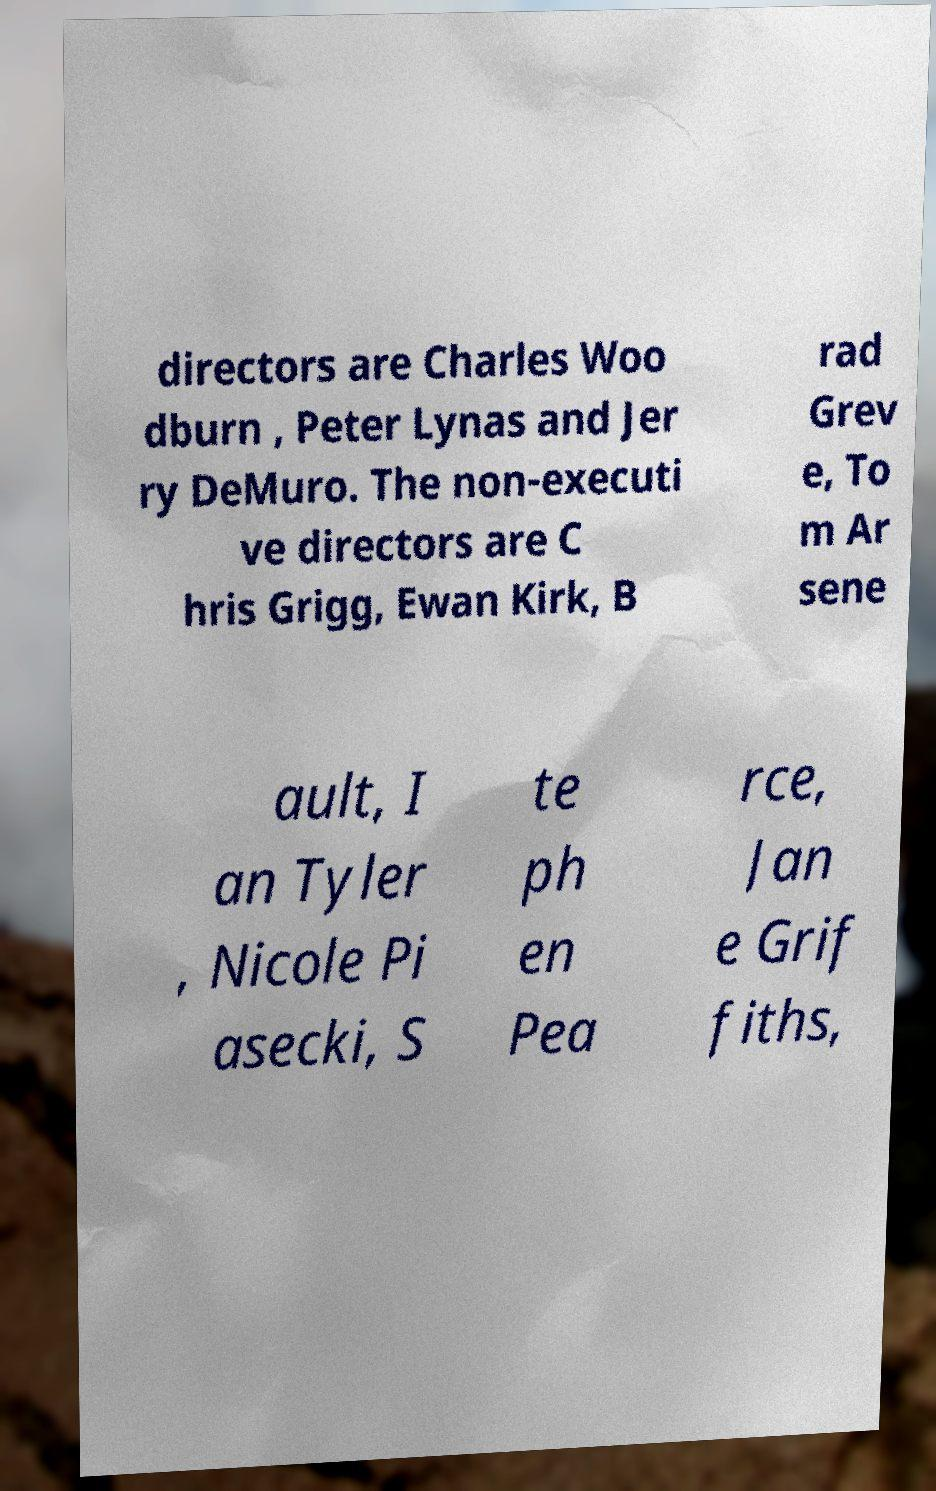What messages or text are displayed in this image? I need them in a readable, typed format. directors are Charles Woo dburn , Peter Lynas and Jer ry DeMuro. The non-executi ve directors are C hris Grigg, Ewan Kirk, B rad Grev e, To m Ar sene ault, I an Tyler , Nicole Pi asecki, S te ph en Pea rce, Jan e Grif fiths, 